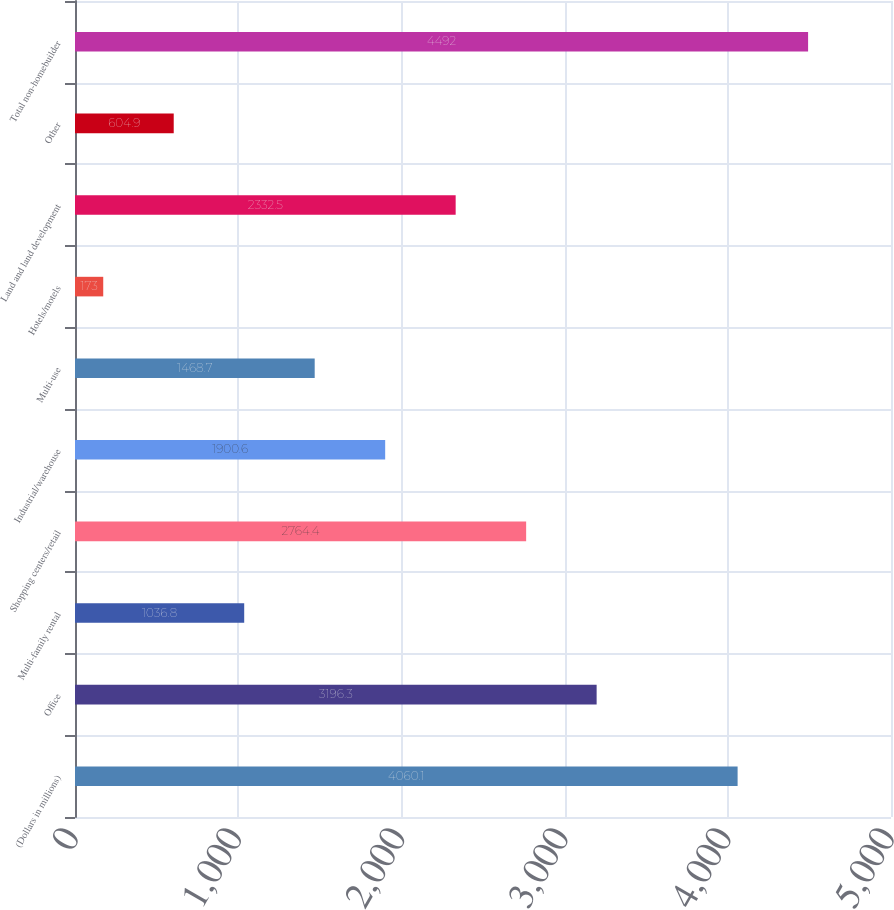<chart> <loc_0><loc_0><loc_500><loc_500><bar_chart><fcel>(Dollars in millions)<fcel>Office<fcel>Multi-family rental<fcel>Shopping centers/retail<fcel>Industrial/warehouse<fcel>Multi-use<fcel>Hotels/motels<fcel>Land and land development<fcel>Other<fcel>Total non-homebuilder<nl><fcel>4060.1<fcel>3196.3<fcel>1036.8<fcel>2764.4<fcel>1900.6<fcel>1468.7<fcel>173<fcel>2332.5<fcel>604.9<fcel>4492<nl></chart> 